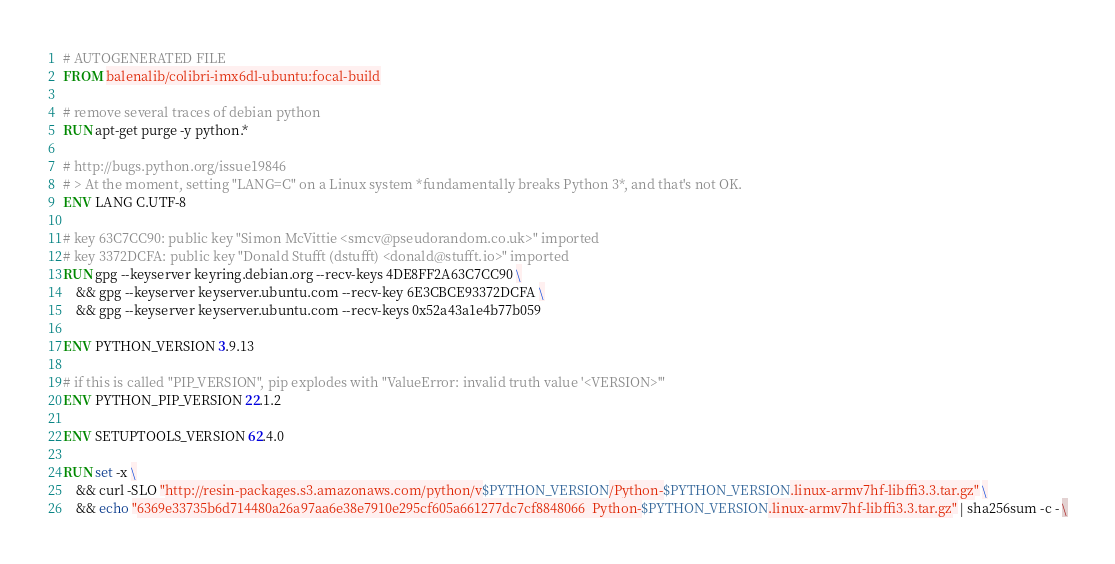Convert code to text. <code><loc_0><loc_0><loc_500><loc_500><_Dockerfile_># AUTOGENERATED FILE
FROM balenalib/colibri-imx6dl-ubuntu:focal-build

# remove several traces of debian python
RUN apt-get purge -y python.*

# http://bugs.python.org/issue19846
# > At the moment, setting "LANG=C" on a Linux system *fundamentally breaks Python 3*, and that's not OK.
ENV LANG C.UTF-8

# key 63C7CC90: public key "Simon McVittie <smcv@pseudorandom.co.uk>" imported
# key 3372DCFA: public key "Donald Stufft (dstufft) <donald@stufft.io>" imported
RUN gpg --keyserver keyring.debian.org --recv-keys 4DE8FF2A63C7CC90 \
	&& gpg --keyserver keyserver.ubuntu.com --recv-key 6E3CBCE93372DCFA \
	&& gpg --keyserver keyserver.ubuntu.com --recv-keys 0x52a43a1e4b77b059

ENV PYTHON_VERSION 3.9.13

# if this is called "PIP_VERSION", pip explodes with "ValueError: invalid truth value '<VERSION>'"
ENV PYTHON_PIP_VERSION 22.1.2

ENV SETUPTOOLS_VERSION 62.4.0

RUN set -x \
	&& curl -SLO "http://resin-packages.s3.amazonaws.com/python/v$PYTHON_VERSION/Python-$PYTHON_VERSION.linux-armv7hf-libffi3.3.tar.gz" \
	&& echo "6369e33735b6d714480a26a97aa6e38e7910e295cf605a661277dc7cf8848066  Python-$PYTHON_VERSION.linux-armv7hf-libffi3.3.tar.gz" | sha256sum -c - \</code> 